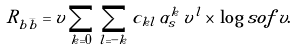<formula> <loc_0><loc_0><loc_500><loc_500>R _ { b \bar { b } } = v \sum _ { k = 0 } \, \sum _ { l = - k } c _ { k l } \, \alpha _ { s } ^ { k } \, v ^ { l } \times \, \log s o f \, v .</formula> 